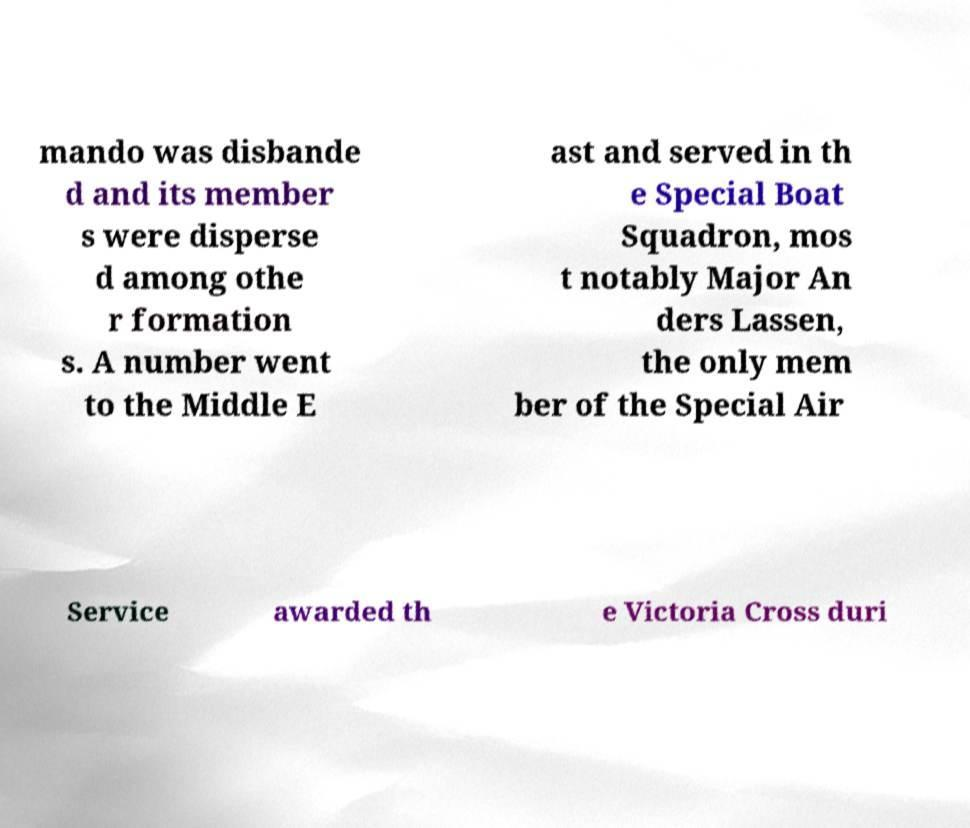What messages or text are displayed in this image? I need them in a readable, typed format. mando was disbande d and its member s were disperse d among othe r formation s. A number went to the Middle E ast and served in th e Special Boat Squadron, mos t notably Major An ders Lassen, the only mem ber of the Special Air Service awarded th e Victoria Cross duri 